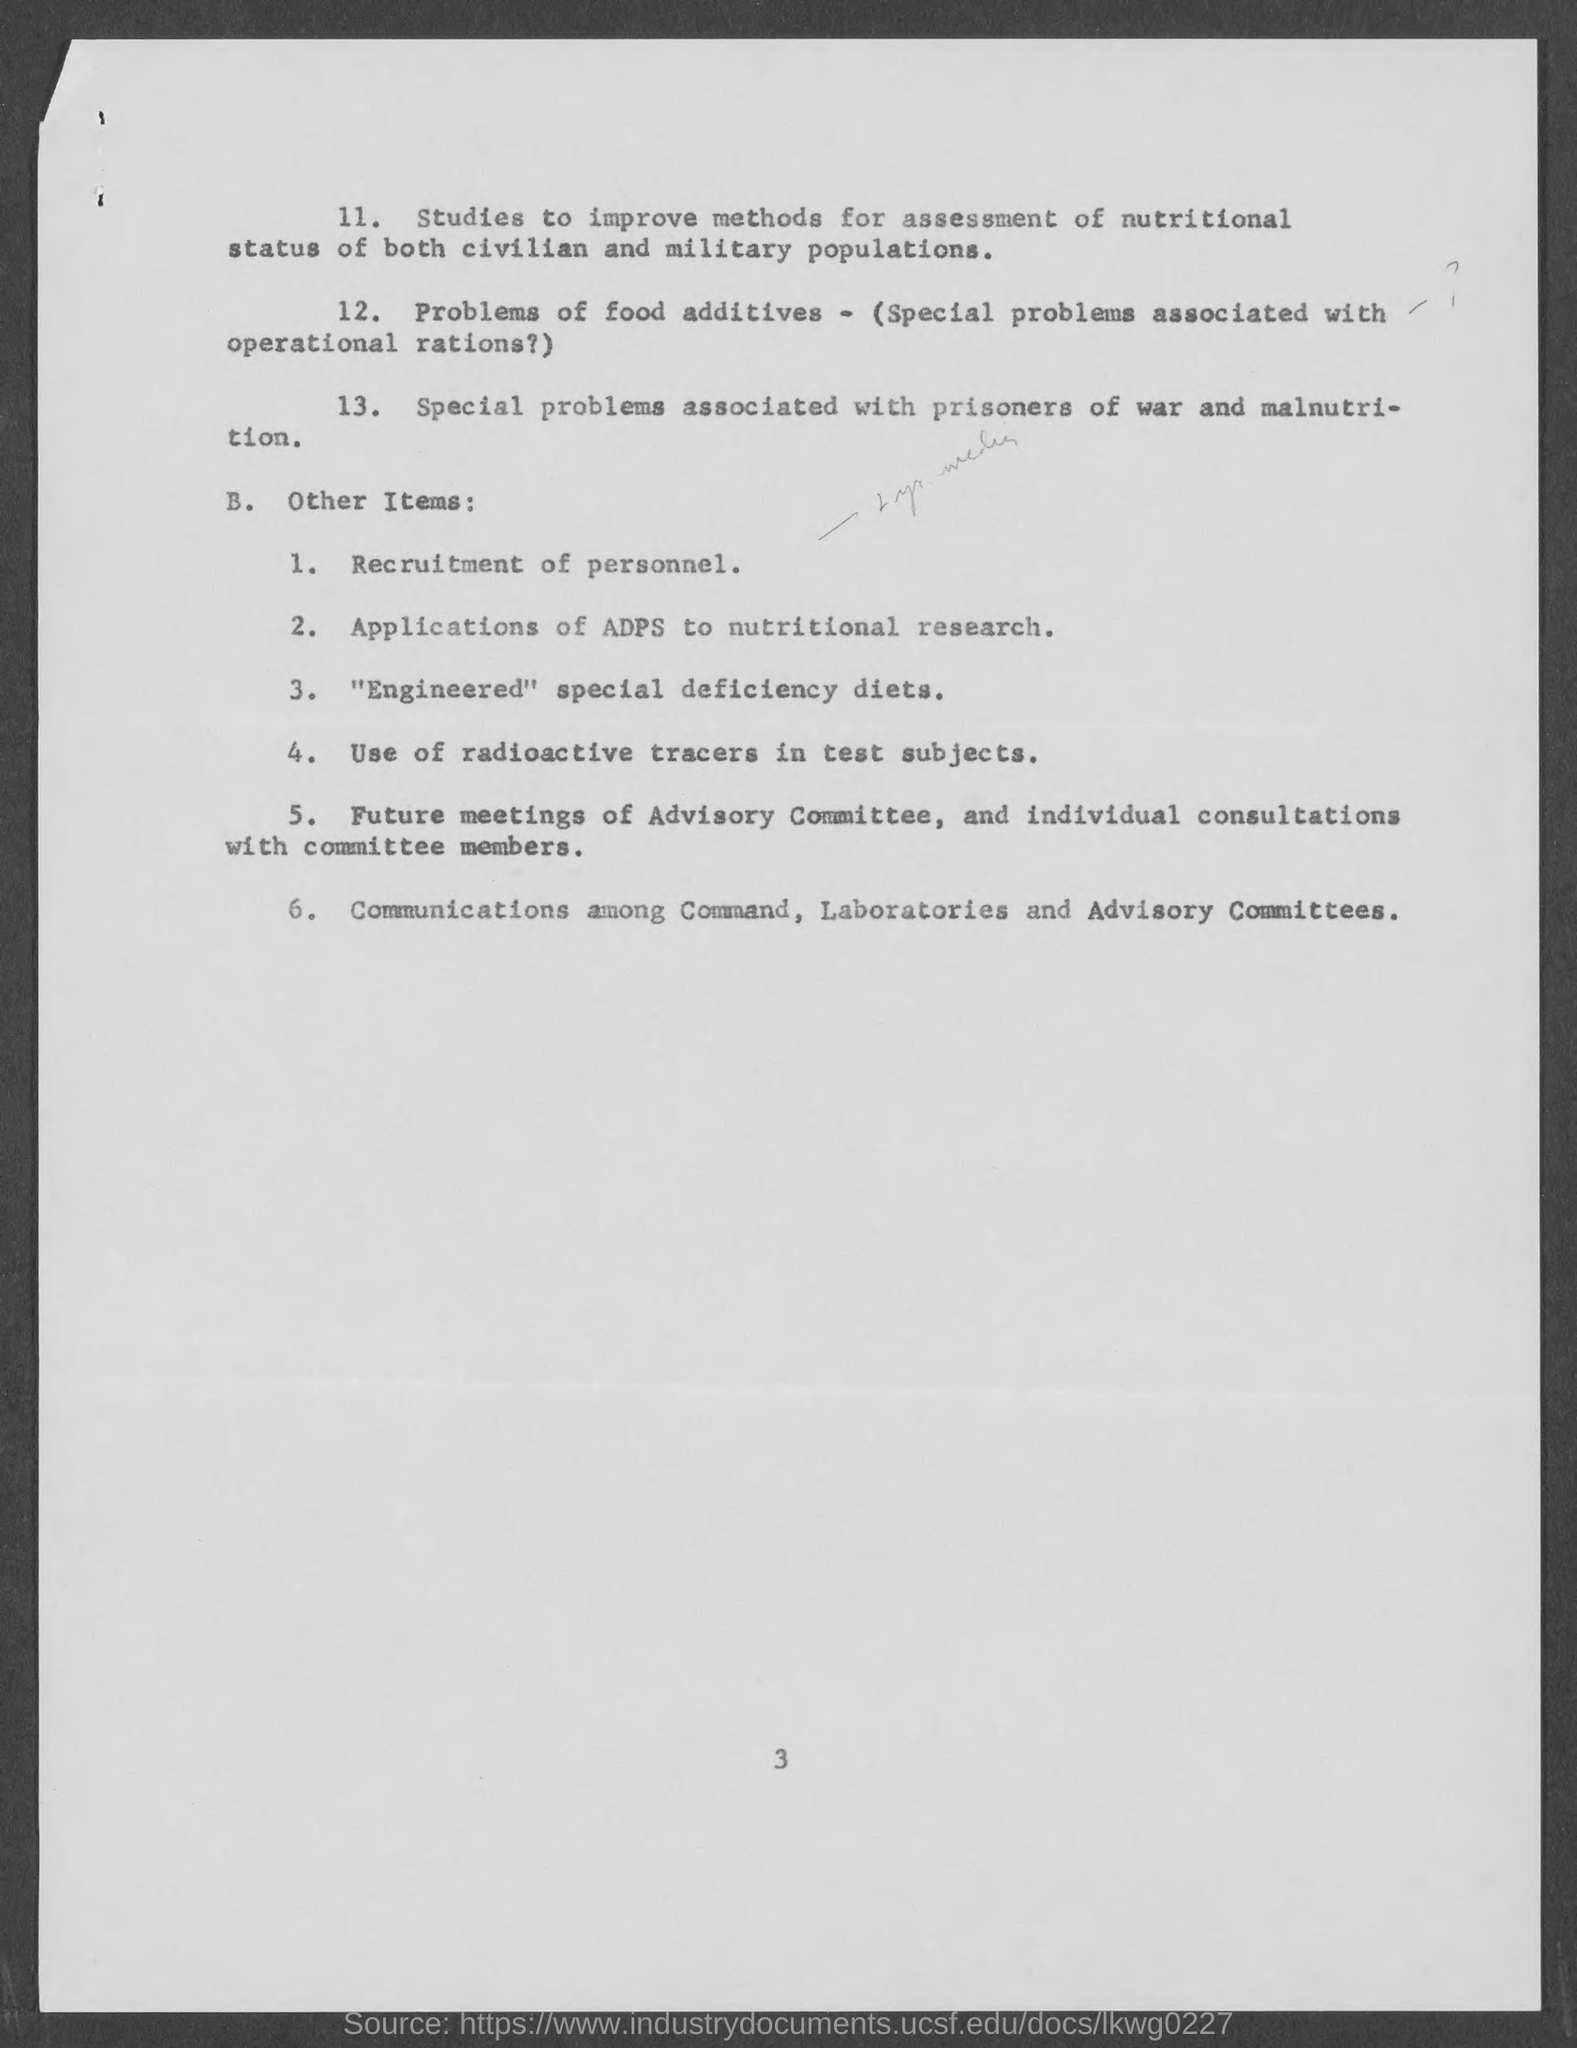Point out several critical features in this image. The page number mentioned at the bottom of the page is 3. 